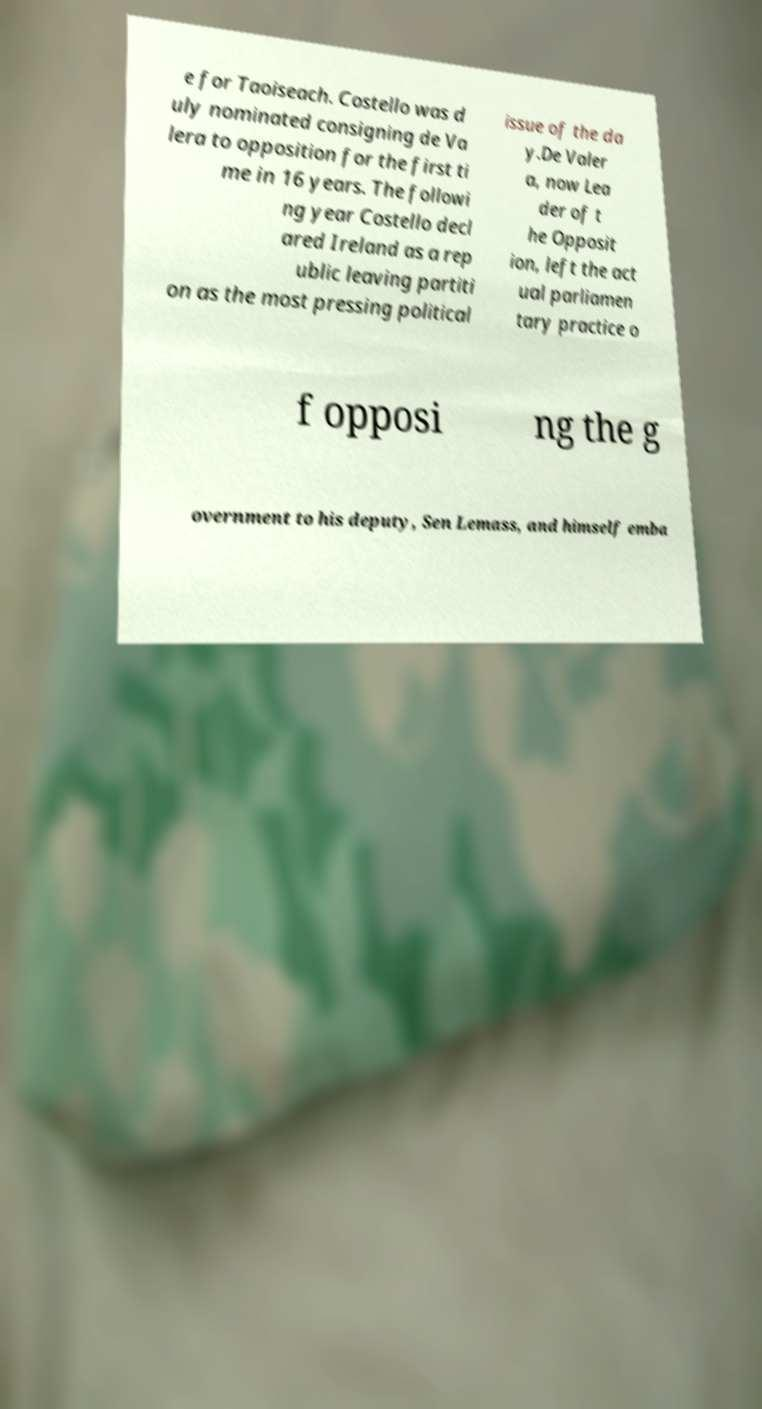Please read and relay the text visible in this image. What does it say? e for Taoiseach. Costello was d uly nominated consigning de Va lera to opposition for the first ti me in 16 years. The followi ng year Costello decl ared Ireland as a rep ublic leaving partiti on as the most pressing political issue of the da y.De Valer a, now Lea der of t he Opposit ion, left the act ual parliamen tary practice o f opposi ng the g overnment to his deputy, Sen Lemass, and himself emba 